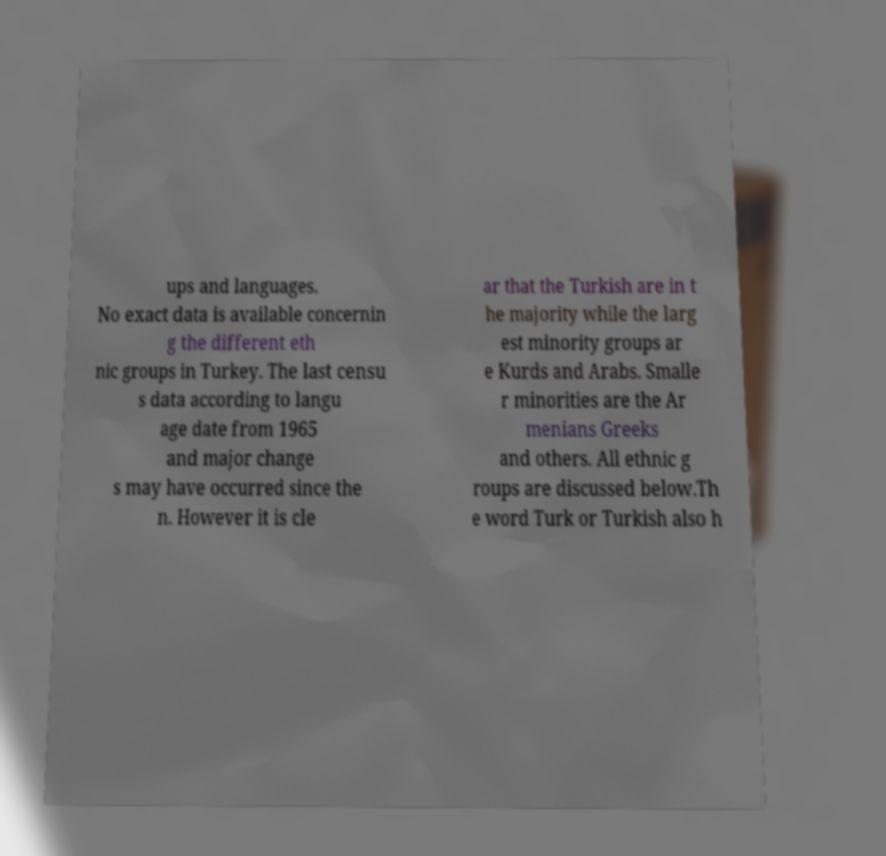Please read and relay the text visible in this image. What does it say? ups and languages. No exact data is available concernin g the different eth nic groups in Turkey. The last censu s data according to langu age date from 1965 and major change s may have occurred since the n. However it is cle ar that the Turkish are in t he majority while the larg est minority groups ar e Kurds and Arabs. Smalle r minorities are the Ar menians Greeks and others. All ethnic g roups are discussed below.Th e word Turk or Turkish also h 